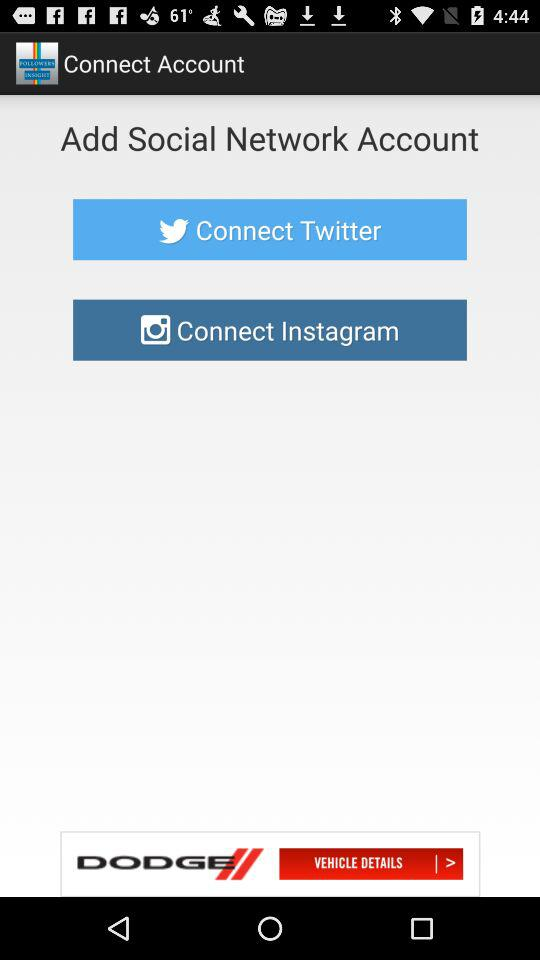What is the app name? The app name is "FOLLOWERS INSIGHT". 